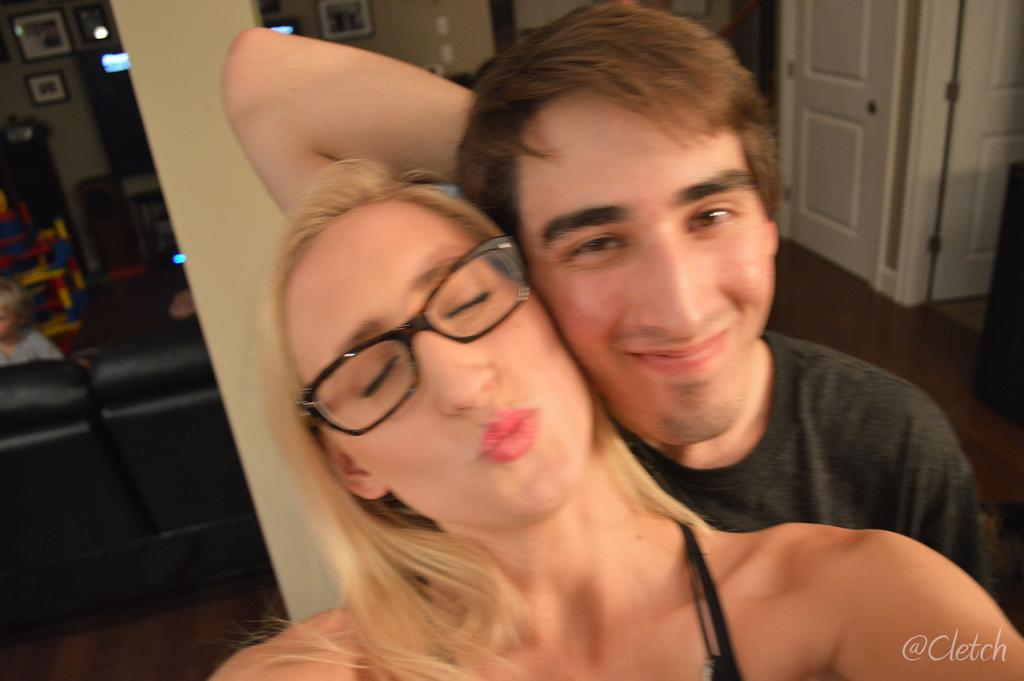How many people are in the image? There are two people in the image. Can you describe what is happening in the background of the image? In the background of the image, there is a child, doors, photo frames, a wall, a sofa, and some objects. What is present in the bottom right corner of the image? There is some text in the bottom right corner of the image. What type of waves can be seen in the image? There are no waves present in the image. What operation is being performed by the people in the image? The image does not depict any operation being performed by the people. 